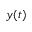<formula> <loc_0><loc_0><loc_500><loc_500>y ( t )</formula> 